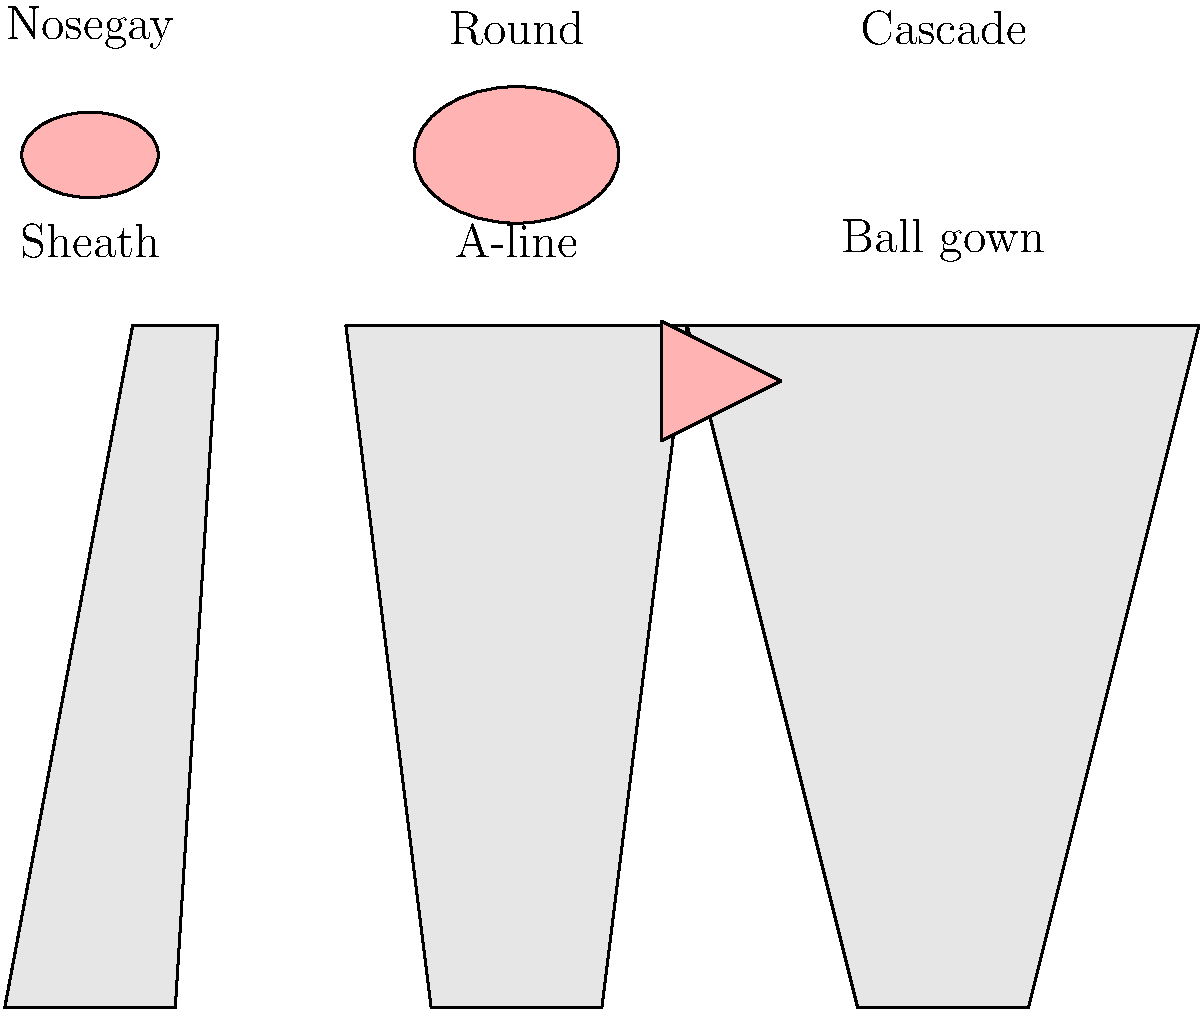Which bouquet style is best suited for a ball gown wedding dress silhouette? To determine the best bouquet style for a ball gown wedding dress silhouette, let's consider the characteristics of each:

1. Ball gown silhouette:
   - Full, voluminous skirt
   - Dramatic and formal appearance
   - Makes a bold statement

2. Bouquet styles:
   a) Nosegay:
      - Small, compact, and round
      - Typically 6-10 inches in diameter
      - Suitable for simpler dress styles

   b) Round:
      - Classic, symmetrical shape
      - Larger than a nosegay, about 10-12 inches in diameter
      - Versatile and works with many dress styles

   c) Cascade:
      - Flowing, dramatic design
      - Features trailing flowers and greenery
      - Creates a waterfall effect

Considering these characteristics:

- The nosegay is too small and simple for the grandeur of a ball gown.
- The round bouquet, while versatile, may not fully complement the dramatic nature of the ball gown.
- The cascade bouquet's flowing, dramatic design mirrors the voluminous and statement-making qualities of the ball gown.

Therefore, the cascade bouquet is the best match for a ball gown wedding dress silhouette, as it complements the dress's drama and creates a cohesive, grand look.
Answer: Cascade 